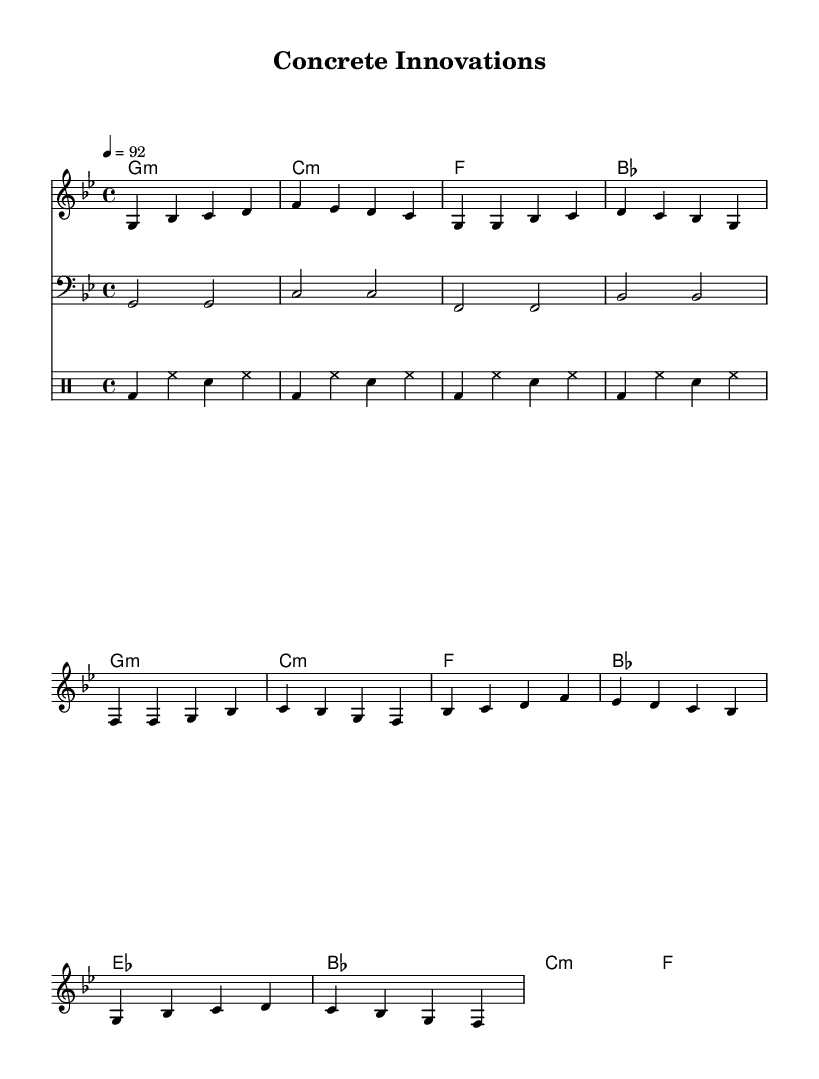What is the key signature of this music? The key signature is G minor, which has two flats (B flat and E flat).
Answer: G minor What is the time signature of this music? The time signature is 4/4, which indicates that there are four beats in each measure and the quarter note gets one beat.
Answer: 4/4 What is the tempo marking in this music? The tempo marking indicates a speed of quarter note equals 92 beats per minute.
Answer: 92 How many measures are in the chorus section? The chorus section contains four measures, as indicated by the melody pattern and chord changes within it.
Answer: 4 Which instrument plays the bass line? The bass line is played on the bass staff, which is typically reserved for lower pitch instruments like the bass guitar or double bass.
Answer: Bass What type of drum pattern is used throughout the piece? The drum pattern is a repeated pattern consisting of bass drums, hi-hat, and snare drums, creating a standard hip-hop rhythm.
Answer: Standard hip-hop rhythm Are there any key changes in this piece? There are no key changes; the music remains in the same key of G minor throughout the piece.
Answer: No 